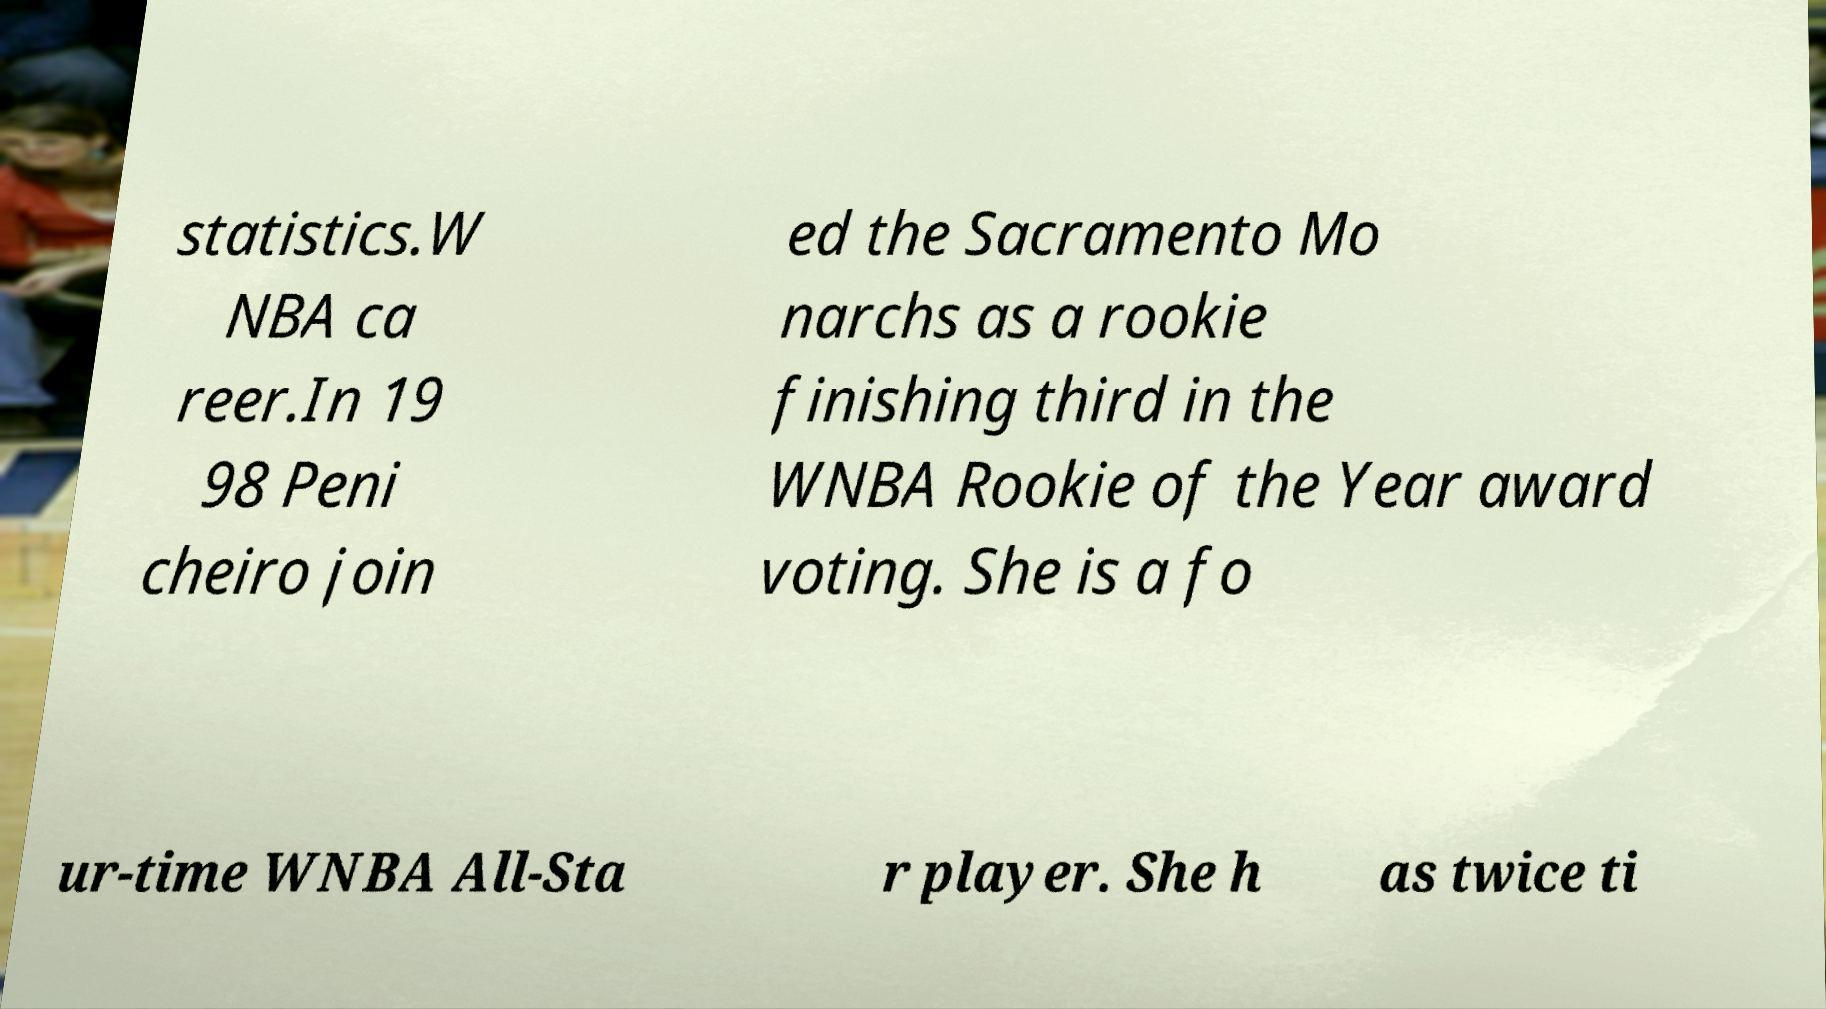For documentation purposes, I need the text within this image transcribed. Could you provide that? statistics.W NBA ca reer.In 19 98 Peni cheiro join ed the Sacramento Mo narchs as a rookie finishing third in the WNBA Rookie of the Year award voting. She is a fo ur-time WNBA All-Sta r player. She h as twice ti 